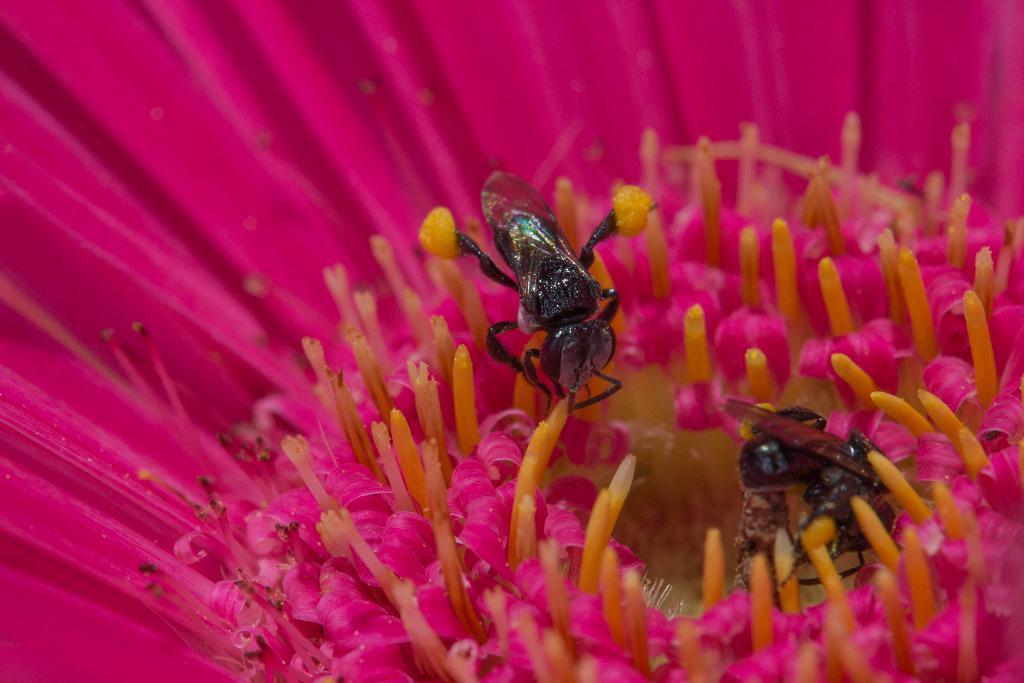Please provide a concise description of this image. In this image we can see a flower which is in pink color and flies on it. 